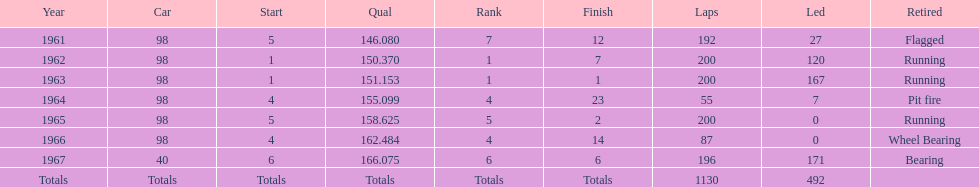What was his highest position before his first triumph? 7. 